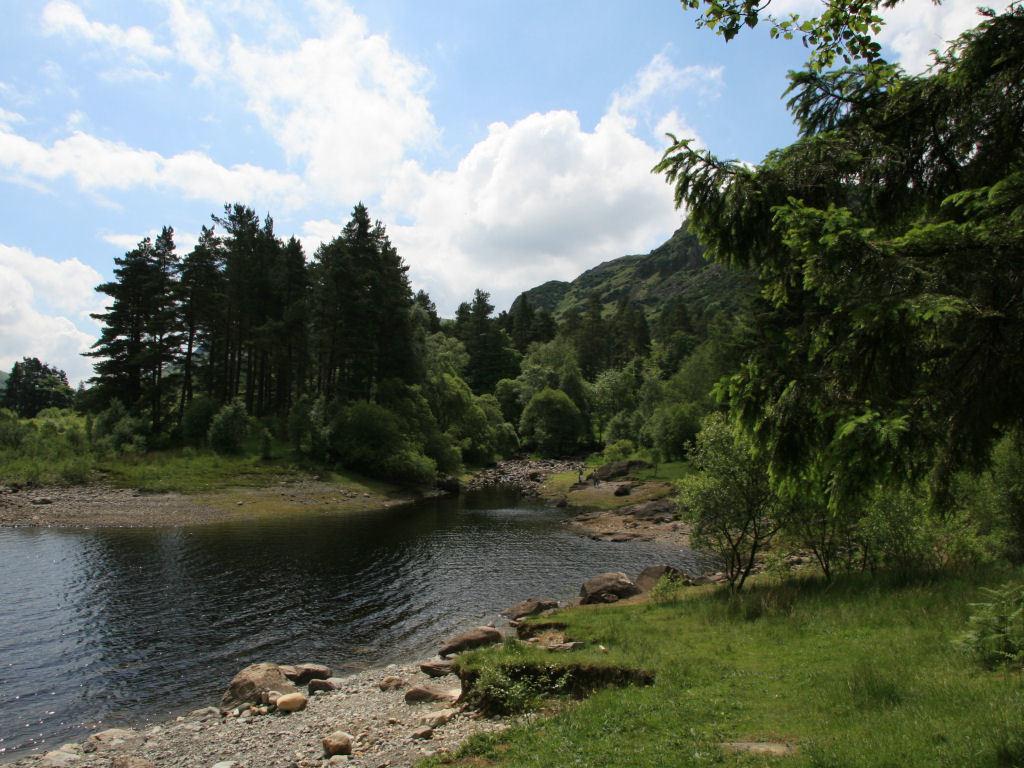Please provide a concise description of this image. In the picture I can see the lake. There are trees on both sides of the lake. I can see the green grass on the right side of the image. There are rocks on the side of the lake. There are clouds in the sky. 